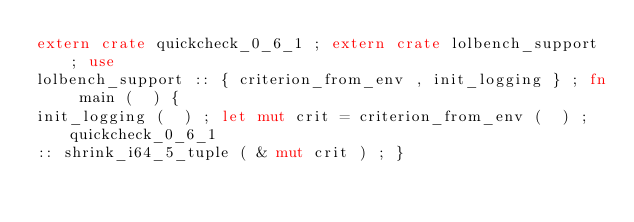Convert code to text. <code><loc_0><loc_0><loc_500><loc_500><_Rust_>extern crate quickcheck_0_6_1 ; extern crate lolbench_support ; use
lolbench_support :: { criterion_from_env , init_logging } ; fn main (  ) {
init_logging (  ) ; let mut crit = criterion_from_env (  ) ; quickcheck_0_6_1
:: shrink_i64_5_tuple ( & mut crit ) ; }</code> 